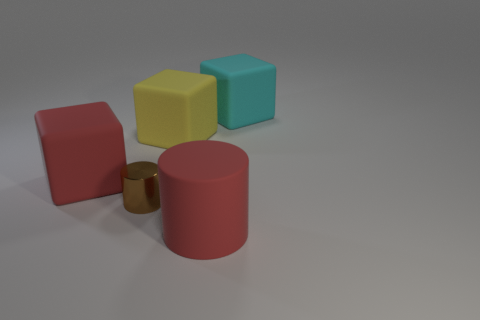Does the cylinder that is left of the large rubber cylinder have the same size as the block behind the yellow rubber cube?
Make the answer very short. No. What number of cubes are big things or tiny metal objects?
Your response must be concise. 3. What number of metallic things are either big red things or tiny purple spheres?
Your answer should be compact. 0. What is the size of the red object that is the same shape as the yellow matte object?
Offer a terse response. Large. Is there anything else that is the same size as the brown thing?
Provide a succinct answer. No. There is a cyan object; does it have the same size as the red thing that is behind the red cylinder?
Ensure brevity in your answer.  Yes. What is the shape of the red matte thing in front of the small brown cylinder?
Your answer should be compact. Cylinder. What color is the big thing that is in front of the big red rubber block that is left of the big yellow object?
Ensure brevity in your answer.  Red. There is a big matte object that is the same shape as the small object; what is its color?
Your answer should be compact. Red. How many metallic things are the same color as the big rubber cylinder?
Provide a short and direct response. 0. 